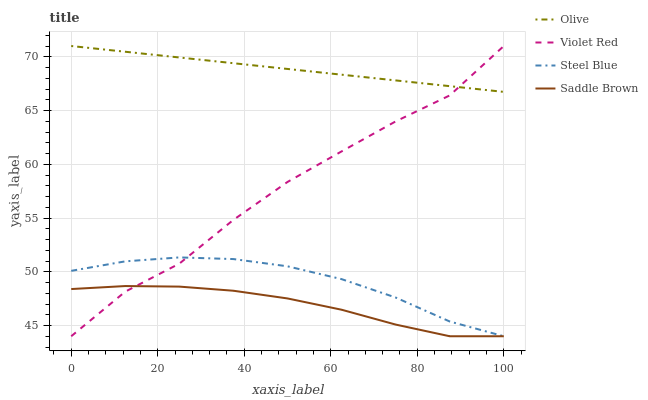Does Saddle Brown have the minimum area under the curve?
Answer yes or no. Yes. Does Olive have the maximum area under the curve?
Answer yes or no. Yes. Does Violet Red have the minimum area under the curve?
Answer yes or no. No. Does Violet Red have the maximum area under the curve?
Answer yes or no. No. Is Olive the smoothest?
Answer yes or no. Yes. Is Violet Red the roughest?
Answer yes or no. Yes. Is Steel Blue the smoothest?
Answer yes or no. No. Is Steel Blue the roughest?
Answer yes or no. No. Does Violet Red have the lowest value?
Answer yes or no. Yes. Does Violet Red have the highest value?
Answer yes or no. Yes. Does Steel Blue have the highest value?
Answer yes or no. No. Is Saddle Brown less than Olive?
Answer yes or no. Yes. Is Olive greater than Steel Blue?
Answer yes or no. Yes. Does Violet Red intersect Steel Blue?
Answer yes or no. Yes. Is Violet Red less than Steel Blue?
Answer yes or no. No. Is Violet Red greater than Steel Blue?
Answer yes or no. No. Does Saddle Brown intersect Olive?
Answer yes or no. No. 